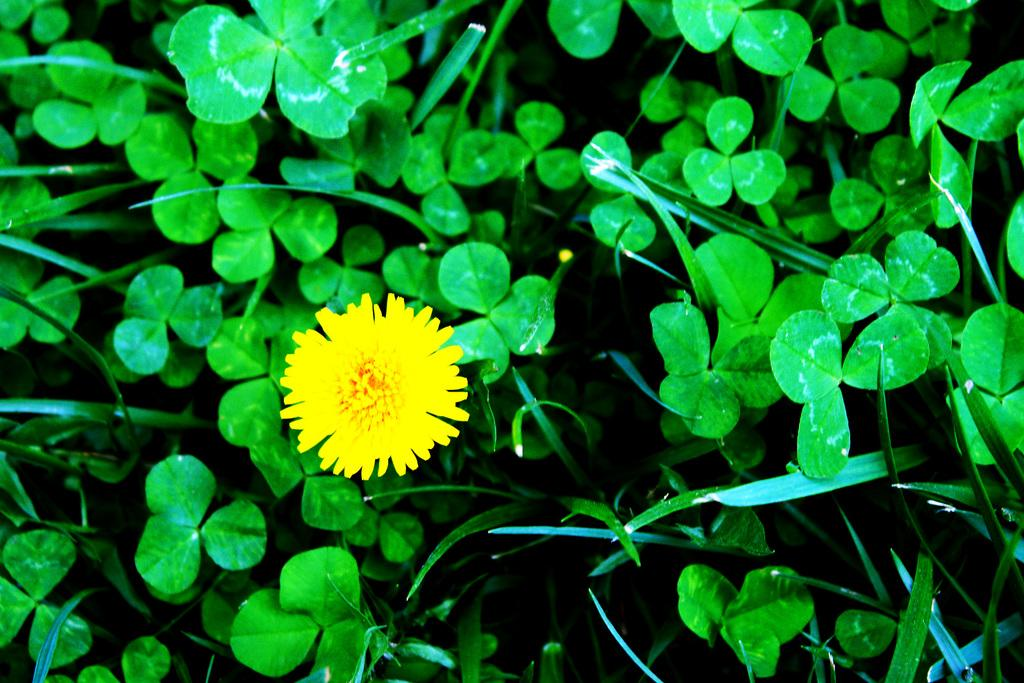What celestial bodies are depicted in the image? There are planets in the image. What type of plant is present in the image? There is a flower in the image. What type of mint can be seen growing near the planets in the image? There is no mint present in the image, as it only features planets and a flower. 